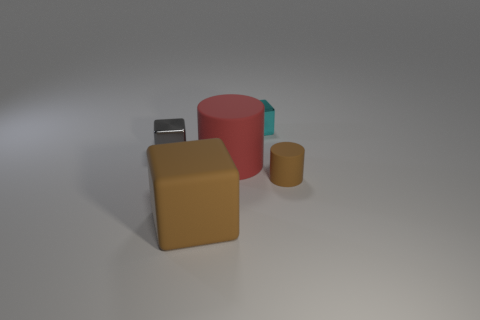How many objects are big blue cubes or tiny things?
Your response must be concise. 3. How many other things are the same shape as the tiny brown rubber thing?
Provide a succinct answer. 1. Do the tiny object in front of the red thing and the object to the left of the large rubber block have the same material?
Keep it short and to the point. No. What is the shape of the tiny object that is both to the right of the large red rubber cylinder and left of the tiny brown thing?
Give a very brief answer. Cube. Are there any other things that are made of the same material as the large red object?
Your response must be concise. Yes. There is a tiny object that is right of the big brown rubber block and on the left side of the tiny cylinder; what material is it made of?
Make the answer very short. Metal. There is a big brown object that is made of the same material as the small brown cylinder; what is its shape?
Give a very brief answer. Cube. Is there any other thing that is the same color as the small rubber cylinder?
Give a very brief answer. Yes. Is the number of small rubber objects that are to the right of the rubber block greater than the number of tiny brown rubber cylinders?
Your answer should be compact. No. What material is the tiny brown object?
Provide a succinct answer. Rubber. 